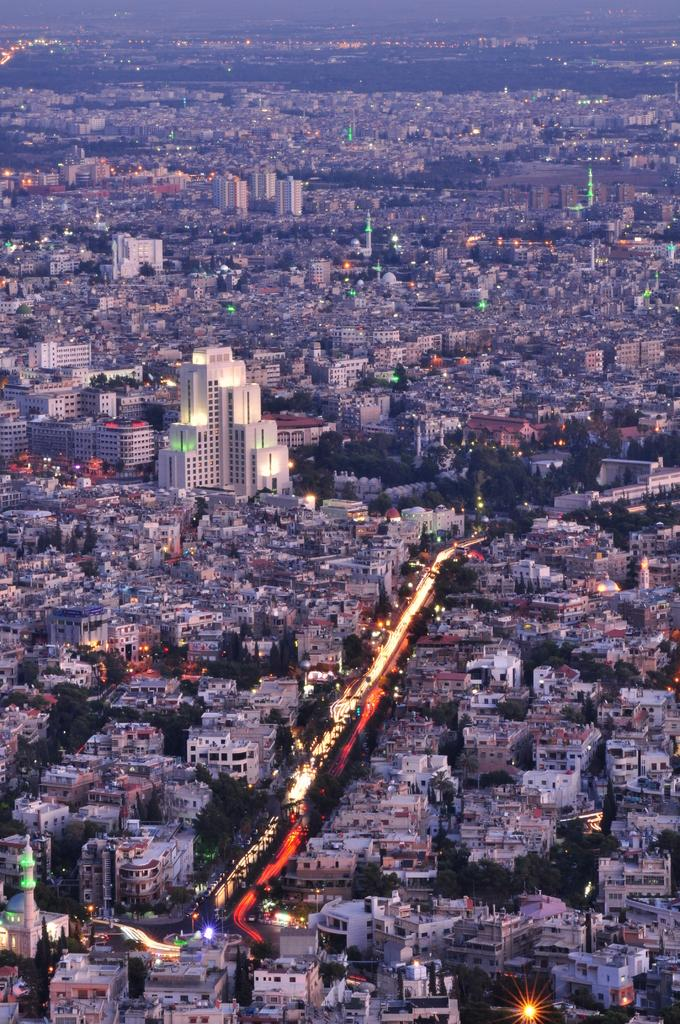What type of structures can be seen in the image? There is a group of buildings in the image. What specific features can be observed on some of the buildings? There are towers in the image. What can be seen illuminating the area in the image? There are lights in the image. What type of natural elements are present in the image? There are trees in the image. What type of pathway is visible in the image? There is a pathway in the image. How do the pets help to maintain the fog in the image? There are no pets or fog present in the image. 